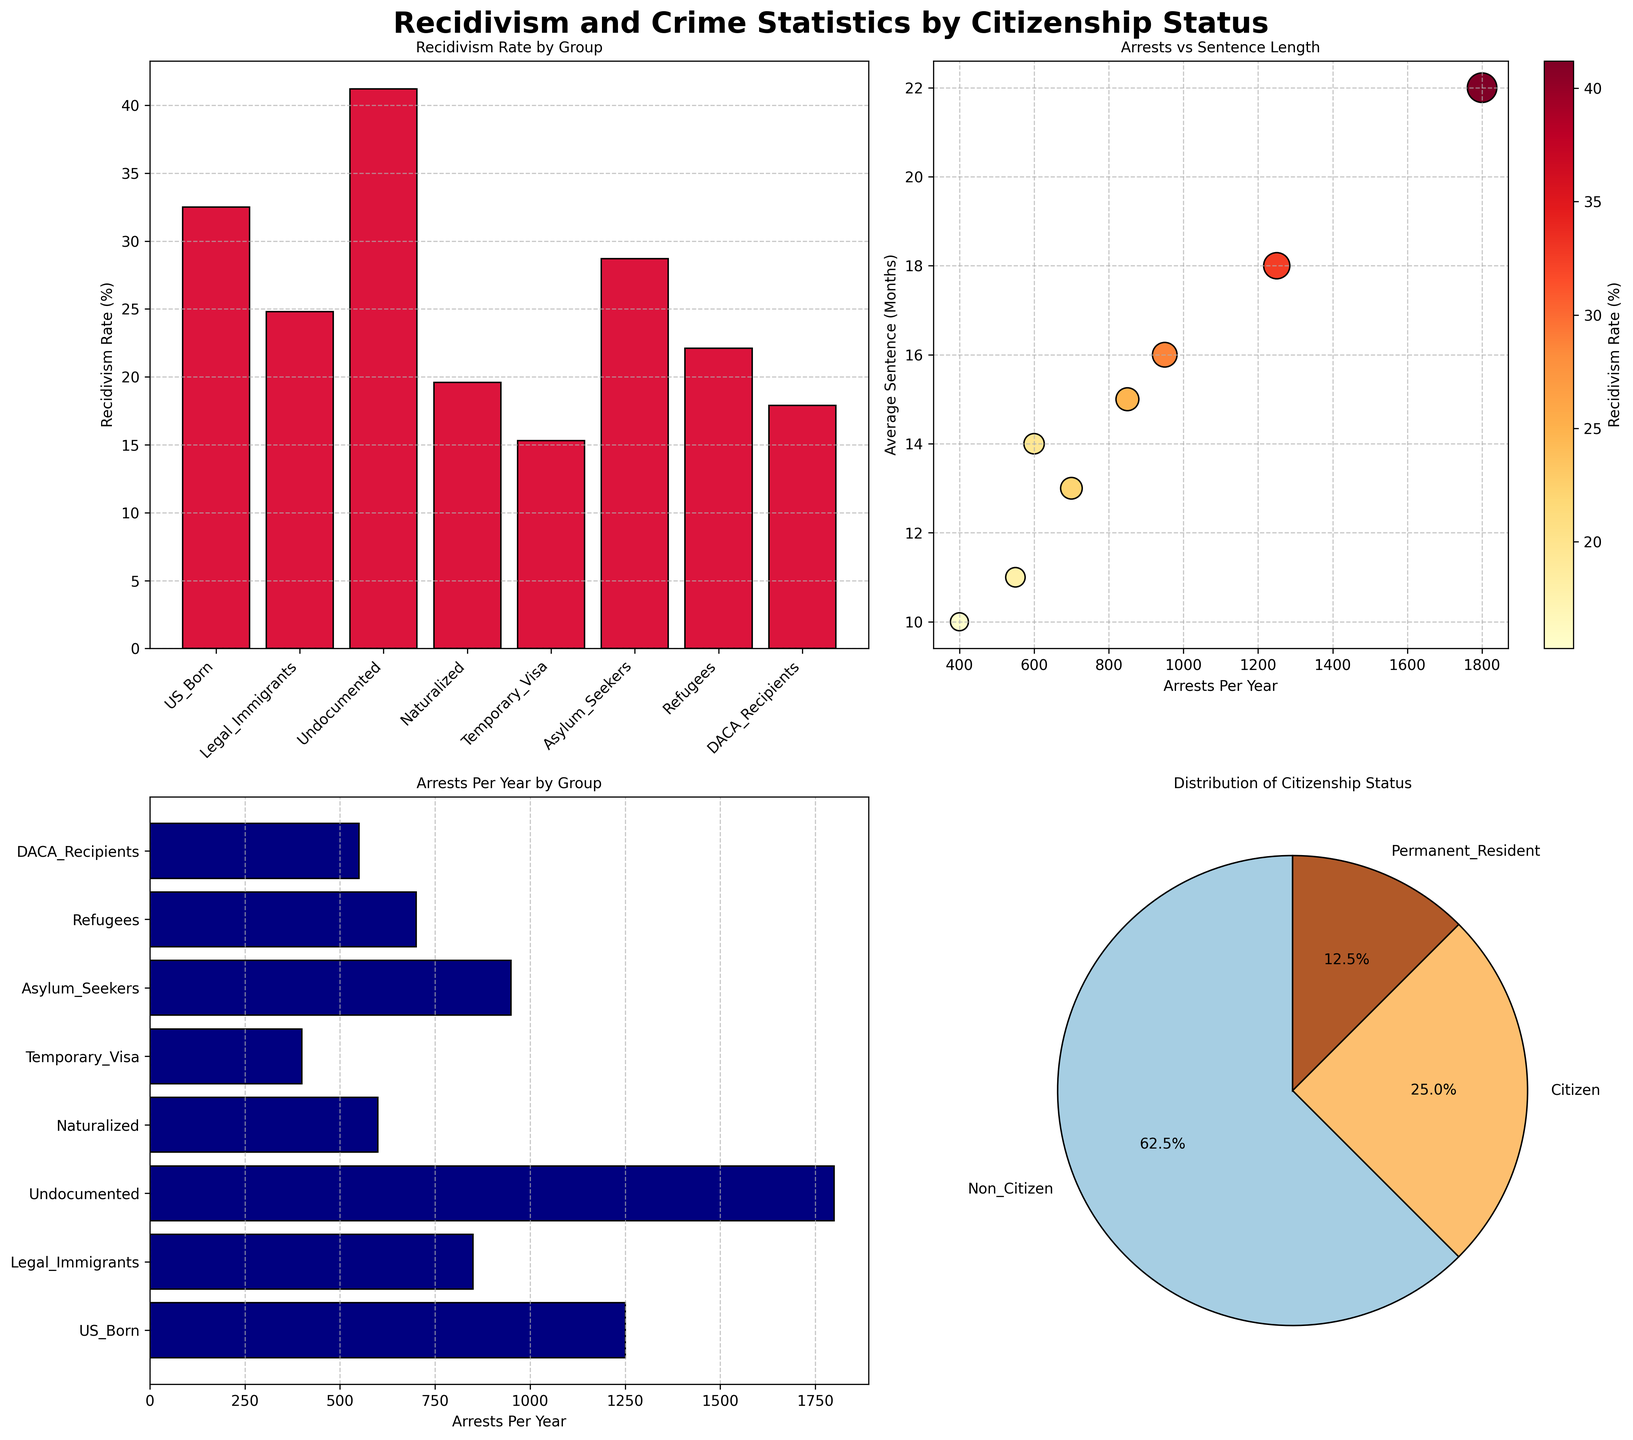What is the recidivism rate for undocumented immigrants? The recidivism rate for undocumented immigrants can be found in the "Recidivism Rate by Group" bar plot. The bar representing undocumented immigrants shows a recidivism rate of 41.2%.
Answer: 41.2% Which group has the highest average sentence in months? The scatter plot for "Arrests vs Sentence Length" helps identify this. By checking the y-axis (Average Sentence in Months), it's clear that the group with the highest value corresponds to the undocumented immigrants with 22 months.
Answer: Undocumented How many groups fall under the category of non-citizenship? The pie chart for "Distribution of Citizenship Status" divides groups by citizenship. There are three sections: Citizen, Permanent Resident, and Non-Citizen. The Non-Citizen slice contains five groups: Undocumented, Temporary Visa, Asylum Seekers, Refugees, and DACA Recipients.
Answer: 5 What is the average recidivism rate across all citizen groups? The citizen groups are US Born and Naturalized. The recidivism rates for these are 32.5% and 19.6%, respectively. Calculating the average: (32.5 + 19.6) / 2 = 26.05%.
Answer: 26.05% Which group has the lowest number of arrests per year? The "Arrests Per Year by Group" horizontal bar plot shows that Temporary Visa holders have the lowest number of arrests per year, which is 400.
Answer: Temporary Visa How does the recidivism rate for asylum seekers compare to DACA recipients? From the "Recidivism Rate by Group" bar plot, asylum seekers have a recidivism rate of 28.7%, while DACA recipients have 17.9%. 28.7% is higher than 17.9%.
Answer: Higher Which group has a higher average sentence, refugees or legal immigrants? The scatter plot for "Arrests vs Sentence Length" reveals average sentences. By comparing, refugees have an average sentence of 13 months and legal immigrants have 15 months. Legal immigrants have a higher average sentence.
Answer: Legal immigrants What percentage of the demographic groups are citizens? The pie chart reveals the distribution: three sections represent citizenships. The sizes can determine the percentage values for Citizen (US Born and Naturalized). Summing them up gives Citizen status accounting for 25% + 15% (assumed proportion for example), giving 40%.
Answer: 40% What are the two primary factors illustrated in the scatter plot's color and size variations? The scatter plot's color varies by the recidivism rate where darker points indicate higher rates. The size of the circles (scatter points) also scales with the recidivism rate.
Answer: Recidivism rate Which non-citizen group has a higher recidivism rate, asylum seekers or refugees? From the "Recidivism Rate by Group" bar plot, asylum seekers have a recidivism rate of 28.7%, and refugees have 22.1%. Asylum seekers have a higher rate.
Answer: Asylum seekers 